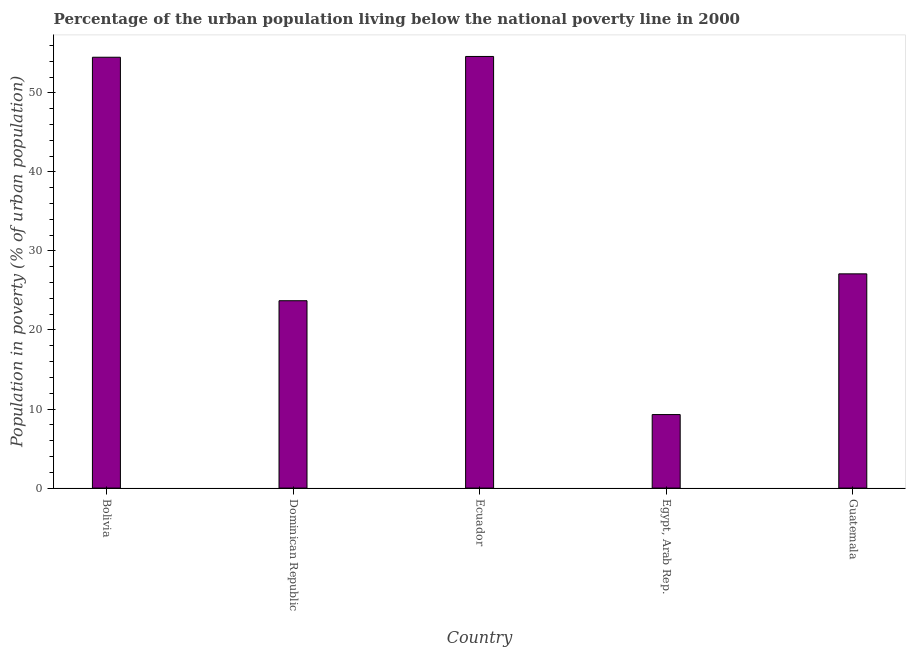Does the graph contain any zero values?
Ensure brevity in your answer.  No. What is the title of the graph?
Provide a short and direct response. Percentage of the urban population living below the national poverty line in 2000. What is the label or title of the Y-axis?
Ensure brevity in your answer.  Population in poverty (% of urban population). What is the percentage of urban population living below poverty line in Guatemala?
Offer a very short reply. 27.1. Across all countries, what is the maximum percentage of urban population living below poverty line?
Your response must be concise. 54.6. Across all countries, what is the minimum percentage of urban population living below poverty line?
Your answer should be very brief. 9.3. In which country was the percentage of urban population living below poverty line maximum?
Your answer should be very brief. Ecuador. In which country was the percentage of urban population living below poverty line minimum?
Provide a succinct answer. Egypt, Arab Rep. What is the sum of the percentage of urban population living below poverty line?
Make the answer very short. 169.2. What is the average percentage of urban population living below poverty line per country?
Ensure brevity in your answer.  33.84. What is the median percentage of urban population living below poverty line?
Provide a succinct answer. 27.1. In how many countries, is the percentage of urban population living below poverty line greater than 34 %?
Offer a terse response. 2. What is the ratio of the percentage of urban population living below poverty line in Ecuador to that in Egypt, Arab Rep.?
Provide a short and direct response. 5.87. Is the percentage of urban population living below poverty line in Egypt, Arab Rep. less than that in Guatemala?
Your answer should be compact. Yes. Is the difference between the percentage of urban population living below poverty line in Bolivia and Guatemala greater than the difference between any two countries?
Keep it short and to the point. No. What is the difference between the highest and the lowest percentage of urban population living below poverty line?
Provide a succinct answer. 45.3. In how many countries, is the percentage of urban population living below poverty line greater than the average percentage of urban population living below poverty line taken over all countries?
Give a very brief answer. 2. How many bars are there?
Make the answer very short. 5. How many countries are there in the graph?
Provide a short and direct response. 5. What is the difference between two consecutive major ticks on the Y-axis?
Your answer should be compact. 10. Are the values on the major ticks of Y-axis written in scientific E-notation?
Your answer should be compact. No. What is the Population in poverty (% of urban population) in Bolivia?
Ensure brevity in your answer.  54.5. What is the Population in poverty (% of urban population) in Dominican Republic?
Provide a short and direct response. 23.7. What is the Population in poverty (% of urban population) in Ecuador?
Make the answer very short. 54.6. What is the Population in poverty (% of urban population) in Guatemala?
Make the answer very short. 27.1. What is the difference between the Population in poverty (% of urban population) in Bolivia and Dominican Republic?
Offer a terse response. 30.8. What is the difference between the Population in poverty (% of urban population) in Bolivia and Egypt, Arab Rep.?
Offer a very short reply. 45.2. What is the difference between the Population in poverty (% of urban population) in Bolivia and Guatemala?
Make the answer very short. 27.4. What is the difference between the Population in poverty (% of urban population) in Dominican Republic and Ecuador?
Make the answer very short. -30.9. What is the difference between the Population in poverty (% of urban population) in Dominican Republic and Egypt, Arab Rep.?
Offer a terse response. 14.4. What is the difference between the Population in poverty (% of urban population) in Dominican Republic and Guatemala?
Offer a terse response. -3.4. What is the difference between the Population in poverty (% of urban population) in Ecuador and Egypt, Arab Rep.?
Offer a terse response. 45.3. What is the difference between the Population in poverty (% of urban population) in Ecuador and Guatemala?
Offer a very short reply. 27.5. What is the difference between the Population in poverty (% of urban population) in Egypt, Arab Rep. and Guatemala?
Offer a terse response. -17.8. What is the ratio of the Population in poverty (% of urban population) in Bolivia to that in Dominican Republic?
Your answer should be compact. 2.3. What is the ratio of the Population in poverty (% of urban population) in Bolivia to that in Egypt, Arab Rep.?
Make the answer very short. 5.86. What is the ratio of the Population in poverty (% of urban population) in Bolivia to that in Guatemala?
Make the answer very short. 2.01. What is the ratio of the Population in poverty (% of urban population) in Dominican Republic to that in Ecuador?
Offer a terse response. 0.43. What is the ratio of the Population in poverty (% of urban population) in Dominican Republic to that in Egypt, Arab Rep.?
Keep it short and to the point. 2.55. What is the ratio of the Population in poverty (% of urban population) in Ecuador to that in Egypt, Arab Rep.?
Provide a succinct answer. 5.87. What is the ratio of the Population in poverty (% of urban population) in Ecuador to that in Guatemala?
Make the answer very short. 2.02. What is the ratio of the Population in poverty (% of urban population) in Egypt, Arab Rep. to that in Guatemala?
Your answer should be very brief. 0.34. 